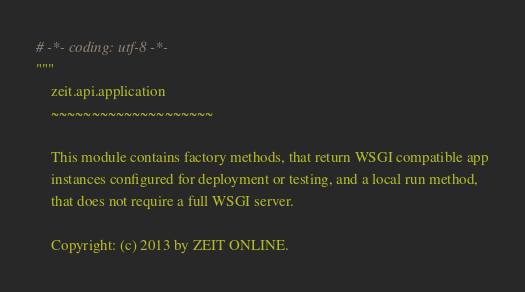Convert code to text. <code><loc_0><loc_0><loc_500><loc_500><_Python_># -*- coding: utf-8 -*-
"""
    zeit.api.application
    ~~~~~~~~~~~~~~~~~~~~

    This module contains factory methods, that return WSGI compatible app
    instances configured for deployment or testing, and a local run method,
    that does not require a full WSGI server.

    Copyright: (c) 2013 by ZEIT ONLINE.</code> 